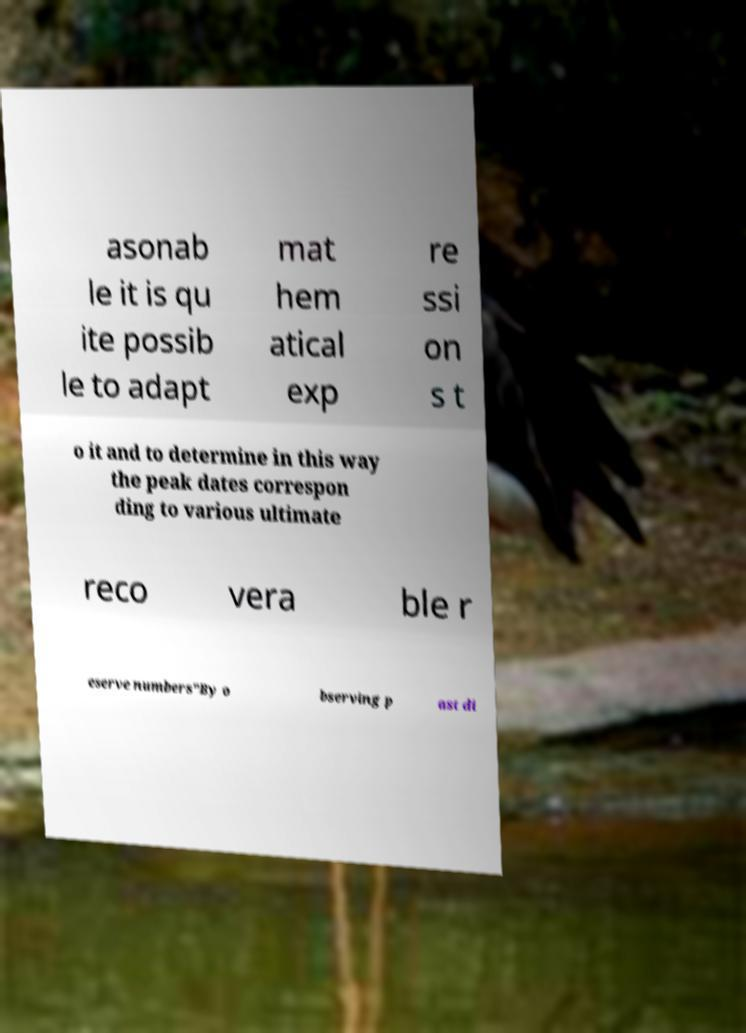Could you extract and type out the text from this image? asonab le it is qu ite possib le to adapt mat hem atical exp re ssi on s t o it and to determine in this way the peak dates correspon ding to various ultimate reco vera ble r eserve numbers"By o bserving p ast di 